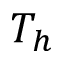Convert formula to latex. <formula><loc_0><loc_0><loc_500><loc_500>T _ { h }</formula> 